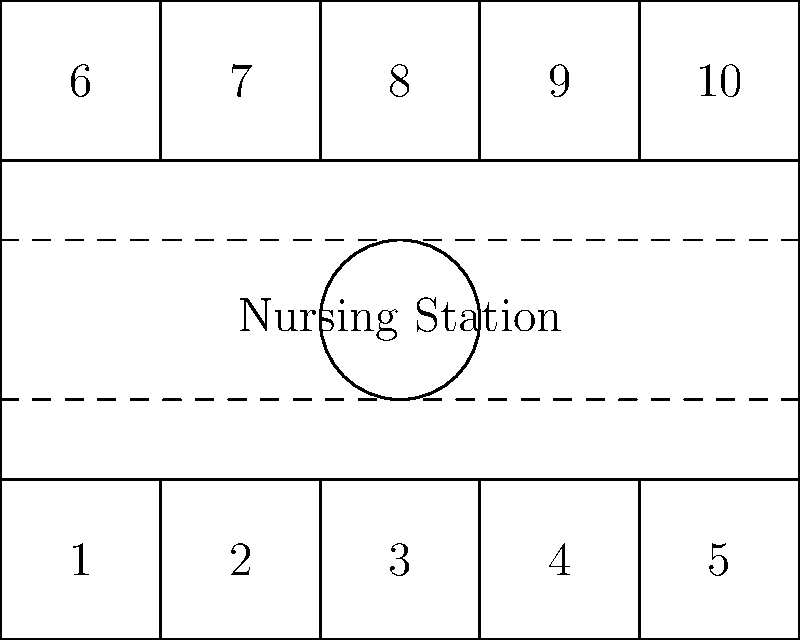Given the hospital floor plan above, which room arrangement would be most efficient for patient care if rooms 1, 4, 6, and 9 need to be designated as isolation rooms for infectious patients? To determine the most efficient arrangement for patient care with isolation rooms, we need to consider several factors:

1. Proximity to the nursing station: Isolation rooms should be easily accessible for frequent monitoring.
2. Distribution of isolation rooms: They should be spread out to minimize the risk of cross-contamination.
3. Traffic flow: The arrangement should minimize the movement of potentially infectious patients through common areas.

Let's analyze the given rooms:
- Rooms 1 and 6 are on one side of the floor.
- Rooms 4 and 9 are on the opposite side.

Step-by-step reasoning:
1. Rooms 1 and 6 are close to each other, which is not ideal for isolation.
2. Rooms 4 and 9 are also close to each other on the opposite side.
3. However, this arrangement creates two separate zones for isolation: one on each side of the floor.
4. The nursing station is centrally located, allowing for quick access to all rooms.
5. The corridor system allows for separate pathways to each isolation room, minimizing cross-traffic.

This arrangement allows for:
- Even distribution of isolation rooms across the floor
- Easy access from the nursing station to all isolation rooms
- Minimal movement of infectious patients through common areas
- Separation of infectious patients on opposite sides of the floor

Therefore, despite the proximity of rooms 1 to 6 and 4 to 9, this arrangement is actually the most efficient for patient care and infection control given the constraints of the floor plan.
Answer: The given arrangement (1, 4, 6, 9) is most efficient. 